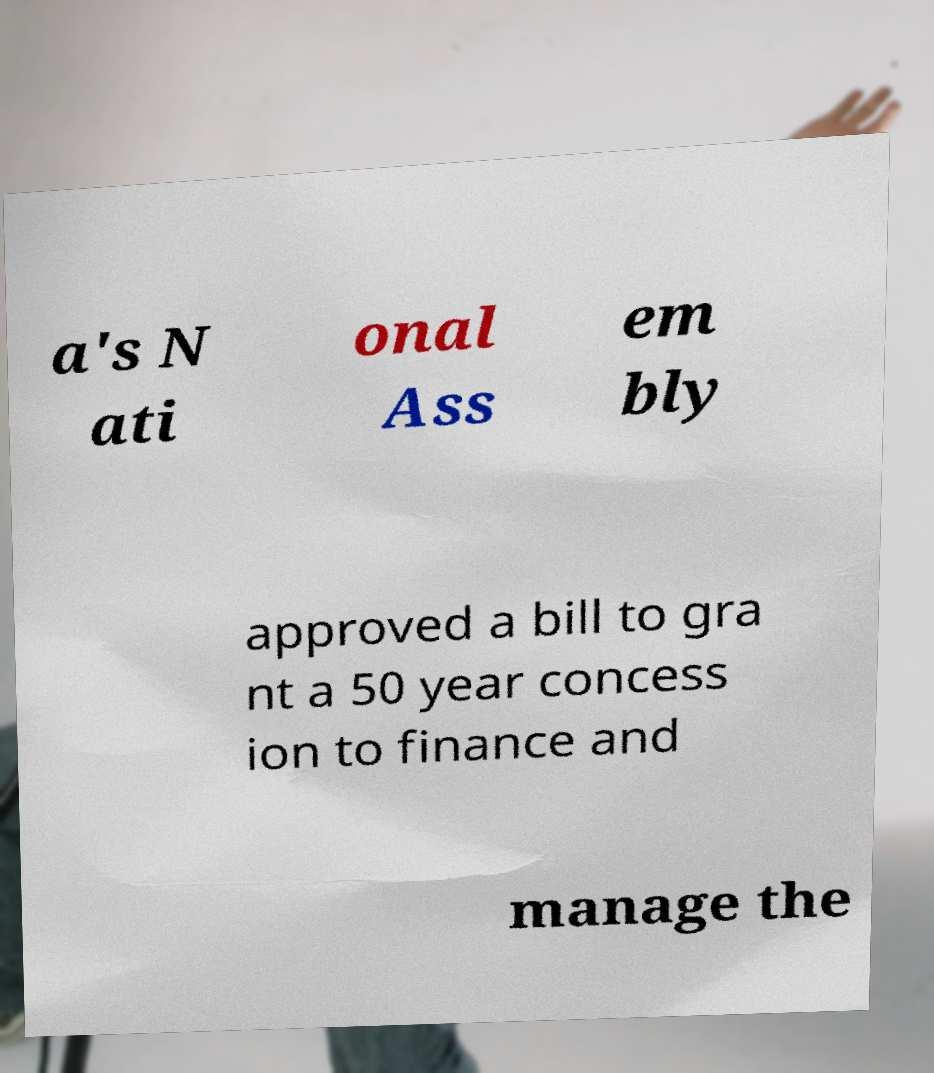What messages or text are displayed in this image? I need them in a readable, typed format. a's N ati onal Ass em bly approved a bill to gra nt a 50 year concess ion to finance and manage the 